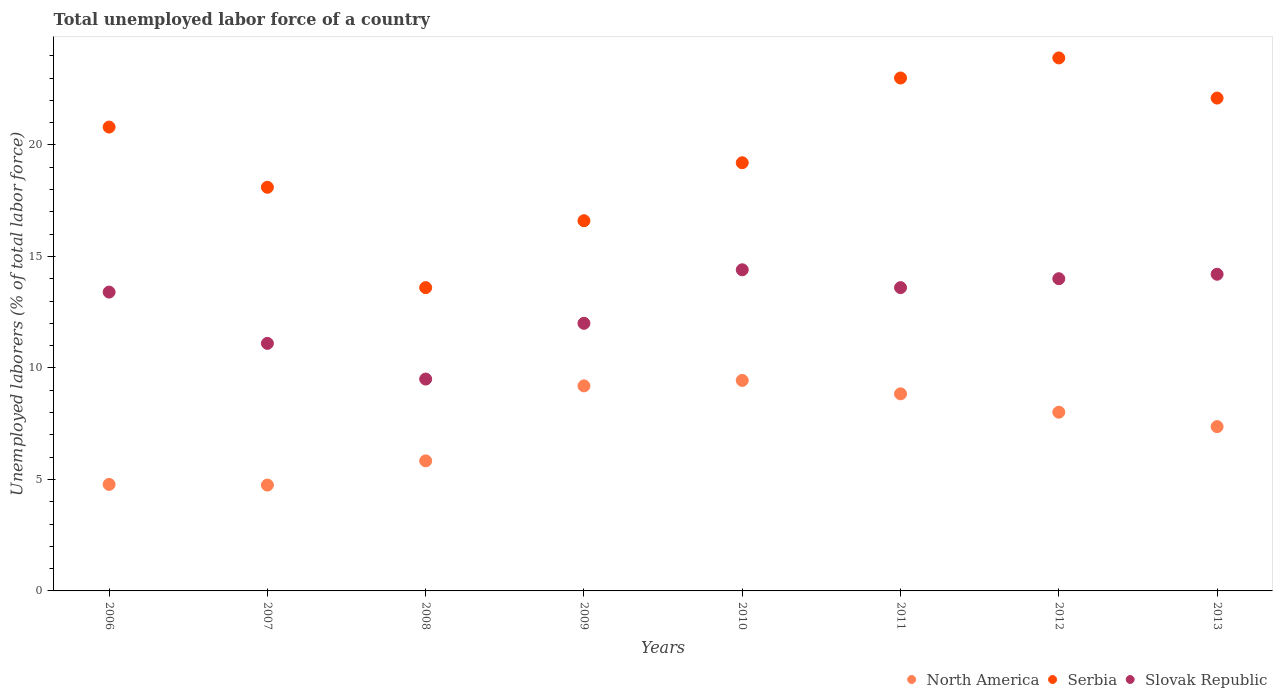How many different coloured dotlines are there?
Offer a terse response. 3. Is the number of dotlines equal to the number of legend labels?
Give a very brief answer. Yes. What is the total unemployed labor force in North America in 2011?
Give a very brief answer. 8.84. Across all years, what is the maximum total unemployed labor force in Slovak Republic?
Offer a very short reply. 14.4. Across all years, what is the minimum total unemployed labor force in Slovak Republic?
Keep it short and to the point. 9.5. In which year was the total unemployed labor force in Slovak Republic maximum?
Give a very brief answer. 2010. What is the total total unemployed labor force in North America in the graph?
Make the answer very short. 58.21. What is the difference between the total unemployed labor force in Slovak Republic in 2009 and that in 2010?
Make the answer very short. -2.4. What is the difference between the total unemployed labor force in Slovak Republic in 2013 and the total unemployed labor force in Serbia in 2010?
Offer a terse response. -5. What is the average total unemployed labor force in Slovak Republic per year?
Offer a very short reply. 12.77. In the year 2012, what is the difference between the total unemployed labor force in North America and total unemployed labor force in Serbia?
Provide a short and direct response. -15.89. What is the ratio of the total unemployed labor force in Serbia in 2009 to that in 2013?
Give a very brief answer. 0.75. What is the difference between the highest and the second highest total unemployed labor force in North America?
Your response must be concise. 0.25. What is the difference between the highest and the lowest total unemployed labor force in Slovak Republic?
Your answer should be very brief. 4.9. In how many years, is the total unemployed labor force in North America greater than the average total unemployed labor force in North America taken over all years?
Provide a succinct answer. 5. Is it the case that in every year, the sum of the total unemployed labor force in Serbia and total unemployed labor force in Slovak Republic  is greater than the total unemployed labor force in North America?
Keep it short and to the point. Yes. Does the total unemployed labor force in Slovak Republic monotonically increase over the years?
Provide a short and direct response. No. Is the total unemployed labor force in North America strictly less than the total unemployed labor force in Slovak Republic over the years?
Ensure brevity in your answer.  Yes. How many dotlines are there?
Provide a succinct answer. 3. Does the graph contain any zero values?
Your answer should be very brief. No. Does the graph contain grids?
Keep it short and to the point. No. Where does the legend appear in the graph?
Your response must be concise. Bottom right. How many legend labels are there?
Your answer should be compact. 3. What is the title of the graph?
Offer a terse response. Total unemployed labor force of a country. What is the label or title of the Y-axis?
Provide a short and direct response. Unemployed laborers (% of total labor force). What is the Unemployed laborers (% of total labor force) of North America in 2006?
Provide a succinct answer. 4.78. What is the Unemployed laborers (% of total labor force) of Serbia in 2006?
Your answer should be very brief. 20.8. What is the Unemployed laborers (% of total labor force) of Slovak Republic in 2006?
Provide a short and direct response. 13.4. What is the Unemployed laborers (% of total labor force) in North America in 2007?
Offer a very short reply. 4.75. What is the Unemployed laborers (% of total labor force) of Serbia in 2007?
Give a very brief answer. 18.1. What is the Unemployed laborers (% of total labor force) in Slovak Republic in 2007?
Ensure brevity in your answer.  11.1. What is the Unemployed laborers (% of total labor force) in North America in 2008?
Your answer should be compact. 5.83. What is the Unemployed laborers (% of total labor force) of Serbia in 2008?
Keep it short and to the point. 13.6. What is the Unemployed laborers (% of total labor force) in North America in 2009?
Your answer should be very brief. 9.19. What is the Unemployed laborers (% of total labor force) in Serbia in 2009?
Offer a terse response. 16.6. What is the Unemployed laborers (% of total labor force) of North America in 2010?
Provide a short and direct response. 9.44. What is the Unemployed laborers (% of total labor force) in Serbia in 2010?
Ensure brevity in your answer.  19.2. What is the Unemployed laborers (% of total labor force) of Slovak Republic in 2010?
Give a very brief answer. 14.4. What is the Unemployed laborers (% of total labor force) in North America in 2011?
Offer a terse response. 8.84. What is the Unemployed laborers (% of total labor force) of Slovak Republic in 2011?
Ensure brevity in your answer.  13.6. What is the Unemployed laborers (% of total labor force) in North America in 2012?
Offer a very short reply. 8.01. What is the Unemployed laborers (% of total labor force) of Serbia in 2012?
Keep it short and to the point. 23.9. What is the Unemployed laborers (% of total labor force) of Slovak Republic in 2012?
Keep it short and to the point. 14. What is the Unemployed laborers (% of total labor force) of North America in 2013?
Your response must be concise. 7.37. What is the Unemployed laborers (% of total labor force) in Serbia in 2013?
Offer a very short reply. 22.1. What is the Unemployed laborers (% of total labor force) of Slovak Republic in 2013?
Provide a succinct answer. 14.2. Across all years, what is the maximum Unemployed laborers (% of total labor force) in North America?
Your response must be concise. 9.44. Across all years, what is the maximum Unemployed laborers (% of total labor force) of Serbia?
Offer a very short reply. 23.9. Across all years, what is the maximum Unemployed laborers (% of total labor force) of Slovak Republic?
Your answer should be compact. 14.4. Across all years, what is the minimum Unemployed laborers (% of total labor force) of North America?
Keep it short and to the point. 4.75. Across all years, what is the minimum Unemployed laborers (% of total labor force) of Serbia?
Ensure brevity in your answer.  13.6. What is the total Unemployed laborers (% of total labor force) of North America in the graph?
Ensure brevity in your answer.  58.21. What is the total Unemployed laborers (% of total labor force) of Serbia in the graph?
Give a very brief answer. 157.3. What is the total Unemployed laborers (% of total labor force) of Slovak Republic in the graph?
Your answer should be very brief. 102.2. What is the difference between the Unemployed laborers (% of total labor force) of North America in 2006 and that in 2007?
Ensure brevity in your answer.  0.03. What is the difference between the Unemployed laborers (% of total labor force) of North America in 2006 and that in 2008?
Make the answer very short. -1.06. What is the difference between the Unemployed laborers (% of total labor force) in Slovak Republic in 2006 and that in 2008?
Offer a terse response. 3.9. What is the difference between the Unemployed laborers (% of total labor force) in North America in 2006 and that in 2009?
Your answer should be compact. -4.42. What is the difference between the Unemployed laborers (% of total labor force) of Serbia in 2006 and that in 2009?
Provide a succinct answer. 4.2. What is the difference between the Unemployed laborers (% of total labor force) in North America in 2006 and that in 2010?
Provide a succinct answer. -4.66. What is the difference between the Unemployed laborers (% of total labor force) of Serbia in 2006 and that in 2010?
Offer a terse response. 1.6. What is the difference between the Unemployed laborers (% of total labor force) of North America in 2006 and that in 2011?
Your response must be concise. -4.06. What is the difference between the Unemployed laborers (% of total labor force) in North America in 2006 and that in 2012?
Make the answer very short. -3.24. What is the difference between the Unemployed laborers (% of total labor force) of Slovak Republic in 2006 and that in 2012?
Offer a terse response. -0.6. What is the difference between the Unemployed laborers (% of total labor force) in North America in 2006 and that in 2013?
Your answer should be compact. -2.59. What is the difference between the Unemployed laborers (% of total labor force) of Serbia in 2006 and that in 2013?
Offer a very short reply. -1.3. What is the difference between the Unemployed laborers (% of total labor force) of Slovak Republic in 2006 and that in 2013?
Provide a short and direct response. -0.8. What is the difference between the Unemployed laborers (% of total labor force) in North America in 2007 and that in 2008?
Make the answer very short. -1.08. What is the difference between the Unemployed laborers (% of total labor force) in Serbia in 2007 and that in 2008?
Your answer should be compact. 4.5. What is the difference between the Unemployed laborers (% of total labor force) of North America in 2007 and that in 2009?
Provide a short and direct response. -4.45. What is the difference between the Unemployed laborers (% of total labor force) of Slovak Republic in 2007 and that in 2009?
Your answer should be compact. -0.9. What is the difference between the Unemployed laborers (% of total labor force) in North America in 2007 and that in 2010?
Offer a very short reply. -4.69. What is the difference between the Unemployed laborers (% of total labor force) of Serbia in 2007 and that in 2010?
Offer a very short reply. -1.1. What is the difference between the Unemployed laborers (% of total labor force) in Slovak Republic in 2007 and that in 2010?
Your answer should be very brief. -3.3. What is the difference between the Unemployed laborers (% of total labor force) of North America in 2007 and that in 2011?
Your response must be concise. -4.09. What is the difference between the Unemployed laborers (% of total labor force) in North America in 2007 and that in 2012?
Ensure brevity in your answer.  -3.27. What is the difference between the Unemployed laborers (% of total labor force) of Serbia in 2007 and that in 2012?
Ensure brevity in your answer.  -5.8. What is the difference between the Unemployed laborers (% of total labor force) of North America in 2007 and that in 2013?
Your response must be concise. -2.62. What is the difference between the Unemployed laborers (% of total labor force) of Serbia in 2007 and that in 2013?
Offer a very short reply. -4. What is the difference between the Unemployed laborers (% of total labor force) of Slovak Republic in 2007 and that in 2013?
Make the answer very short. -3.1. What is the difference between the Unemployed laborers (% of total labor force) of North America in 2008 and that in 2009?
Keep it short and to the point. -3.36. What is the difference between the Unemployed laborers (% of total labor force) in Slovak Republic in 2008 and that in 2009?
Give a very brief answer. -2.5. What is the difference between the Unemployed laborers (% of total labor force) of North America in 2008 and that in 2010?
Ensure brevity in your answer.  -3.61. What is the difference between the Unemployed laborers (% of total labor force) in Serbia in 2008 and that in 2010?
Provide a succinct answer. -5.6. What is the difference between the Unemployed laborers (% of total labor force) of Slovak Republic in 2008 and that in 2010?
Offer a terse response. -4.9. What is the difference between the Unemployed laborers (% of total labor force) in North America in 2008 and that in 2011?
Make the answer very short. -3.01. What is the difference between the Unemployed laborers (% of total labor force) in Slovak Republic in 2008 and that in 2011?
Your response must be concise. -4.1. What is the difference between the Unemployed laborers (% of total labor force) in North America in 2008 and that in 2012?
Offer a terse response. -2.18. What is the difference between the Unemployed laborers (% of total labor force) of Slovak Republic in 2008 and that in 2012?
Your answer should be very brief. -4.5. What is the difference between the Unemployed laborers (% of total labor force) of North America in 2008 and that in 2013?
Your answer should be very brief. -1.54. What is the difference between the Unemployed laborers (% of total labor force) in North America in 2009 and that in 2010?
Ensure brevity in your answer.  -0.25. What is the difference between the Unemployed laborers (% of total labor force) in Serbia in 2009 and that in 2010?
Keep it short and to the point. -2.6. What is the difference between the Unemployed laborers (% of total labor force) in Slovak Republic in 2009 and that in 2010?
Make the answer very short. -2.4. What is the difference between the Unemployed laborers (% of total labor force) in North America in 2009 and that in 2011?
Provide a succinct answer. 0.36. What is the difference between the Unemployed laborers (% of total labor force) in Serbia in 2009 and that in 2011?
Ensure brevity in your answer.  -6.4. What is the difference between the Unemployed laborers (% of total labor force) of North America in 2009 and that in 2012?
Offer a very short reply. 1.18. What is the difference between the Unemployed laborers (% of total labor force) in Slovak Republic in 2009 and that in 2012?
Your answer should be very brief. -2. What is the difference between the Unemployed laborers (% of total labor force) of North America in 2009 and that in 2013?
Ensure brevity in your answer.  1.83. What is the difference between the Unemployed laborers (% of total labor force) in Serbia in 2009 and that in 2013?
Offer a very short reply. -5.5. What is the difference between the Unemployed laborers (% of total labor force) of Slovak Republic in 2009 and that in 2013?
Ensure brevity in your answer.  -2.2. What is the difference between the Unemployed laborers (% of total labor force) of North America in 2010 and that in 2011?
Offer a very short reply. 0.6. What is the difference between the Unemployed laborers (% of total labor force) in Slovak Republic in 2010 and that in 2011?
Your response must be concise. 0.8. What is the difference between the Unemployed laborers (% of total labor force) in North America in 2010 and that in 2012?
Ensure brevity in your answer.  1.43. What is the difference between the Unemployed laborers (% of total labor force) of North America in 2010 and that in 2013?
Provide a succinct answer. 2.07. What is the difference between the Unemployed laborers (% of total labor force) in Serbia in 2010 and that in 2013?
Your response must be concise. -2.9. What is the difference between the Unemployed laborers (% of total labor force) of Slovak Republic in 2010 and that in 2013?
Your response must be concise. 0.2. What is the difference between the Unemployed laborers (% of total labor force) of North America in 2011 and that in 2012?
Make the answer very short. 0.82. What is the difference between the Unemployed laborers (% of total labor force) in Serbia in 2011 and that in 2012?
Provide a succinct answer. -0.9. What is the difference between the Unemployed laborers (% of total labor force) of Slovak Republic in 2011 and that in 2012?
Keep it short and to the point. -0.4. What is the difference between the Unemployed laborers (% of total labor force) in North America in 2011 and that in 2013?
Your answer should be compact. 1.47. What is the difference between the Unemployed laborers (% of total labor force) of Serbia in 2011 and that in 2013?
Your answer should be very brief. 0.9. What is the difference between the Unemployed laborers (% of total labor force) of North America in 2012 and that in 2013?
Keep it short and to the point. 0.65. What is the difference between the Unemployed laborers (% of total labor force) in Serbia in 2012 and that in 2013?
Give a very brief answer. 1.8. What is the difference between the Unemployed laborers (% of total labor force) of North America in 2006 and the Unemployed laborers (% of total labor force) of Serbia in 2007?
Provide a succinct answer. -13.32. What is the difference between the Unemployed laborers (% of total labor force) in North America in 2006 and the Unemployed laborers (% of total labor force) in Slovak Republic in 2007?
Your answer should be very brief. -6.32. What is the difference between the Unemployed laborers (% of total labor force) of North America in 2006 and the Unemployed laborers (% of total labor force) of Serbia in 2008?
Provide a short and direct response. -8.82. What is the difference between the Unemployed laborers (% of total labor force) of North America in 2006 and the Unemployed laborers (% of total labor force) of Slovak Republic in 2008?
Ensure brevity in your answer.  -4.72. What is the difference between the Unemployed laborers (% of total labor force) in Serbia in 2006 and the Unemployed laborers (% of total labor force) in Slovak Republic in 2008?
Keep it short and to the point. 11.3. What is the difference between the Unemployed laborers (% of total labor force) of North America in 2006 and the Unemployed laborers (% of total labor force) of Serbia in 2009?
Keep it short and to the point. -11.82. What is the difference between the Unemployed laborers (% of total labor force) in North America in 2006 and the Unemployed laborers (% of total labor force) in Slovak Republic in 2009?
Your response must be concise. -7.22. What is the difference between the Unemployed laborers (% of total labor force) in North America in 2006 and the Unemployed laborers (% of total labor force) in Serbia in 2010?
Offer a very short reply. -14.42. What is the difference between the Unemployed laborers (% of total labor force) of North America in 2006 and the Unemployed laborers (% of total labor force) of Slovak Republic in 2010?
Offer a terse response. -9.62. What is the difference between the Unemployed laborers (% of total labor force) in North America in 2006 and the Unemployed laborers (% of total labor force) in Serbia in 2011?
Ensure brevity in your answer.  -18.22. What is the difference between the Unemployed laborers (% of total labor force) of North America in 2006 and the Unemployed laborers (% of total labor force) of Slovak Republic in 2011?
Keep it short and to the point. -8.82. What is the difference between the Unemployed laborers (% of total labor force) of Serbia in 2006 and the Unemployed laborers (% of total labor force) of Slovak Republic in 2011?
Offer a terse response. 7.2. What is the difference between the Unemployed laborers (% of total labor force) in North America in 2006 and the Unemployed laborers (% of total labor force) in Serbia in 2012?
Provide a short and direct response. -19.12. What is the difference between the Unemployed laborers (% of total labor force) of North America in 2006 and the Unemployed laborers (% of total labor force) of Slovak Republic in 2012?
Provide a short and direct response. -9.22. What is the difference between the Unemployed laborers (% of total labor force) of Serbia in 2006 and the Unemployed laborers (% of total labor force) of Slovak Republic in 2012?
Make the answer very short. 6.8. What is the difference between the Unemployed laborers (% of total labor force) in North America in 2006 and the Unemployed laborers (% of total labor force) in Serbia in 2013?
Your answer should be compact. -17.32. What is the difference between the Unemployed laborers (% of total labor force) of North America in 2006 and the Unemployed laborers (% of total labor force) of Slovak Republic in 2013?
Offer a terse response. -9.42. What is the difference between the Unemployed laborers (% of total labor force) in North America in 2007 and the Unemployed laborers (% of total labor force) in Serbia in 2008?
Keep it short and to the point. -8.85. What is the difference between the Unemployed laborers (% of total labor force) of North America in 2007 and the Unemployed laborers (% of total labor force) of Slovak Republic in 2008?
Your answer should be compact. -4.75. What is the difference between the Unemployed laborers (% of total labor force) in Serbia in 2007 and the Unemployed laborers (% of total labor force) in Slovak Republic in 2008?
Make the answer very short. 8.6. What is the difference between the Unemployed laborers (% of total labor force) of North America in 2007 and the Unemployed laborers (% of total labor force) of Serbia in 2009?
Keep it short and to the point. -11.85. What is the difference between the Unemployed laborers (% of total labor force) of North America in 2007 and the Unemployed laborers (% of total labor force) of Slovak Republic in 2009?
Make the answer very short. -7.25. What is the difference between the Unemployed laborers (% of total labor force) of Serbia in 2007 and the Unemployed laborers (% of total labor force) of Slovak Republic in 2009?
Your response must be concise. 6.1. What is the difference between the Unemployed laborers (% of total labor force) of North America in 2007 and the Unemployed laborers (% of total labor force) of Serbia in 2010?
Your answer should be compact. -14.45. What is the difference between the Unemployed laborers (% of total labor force) of North America in 2007 and the Unemployed laborers (% of total labor force) of Slovak Republic in 2010?
Make the answer very short. -9.65. What is the difference between the Unemployed laborers (% of total labor force) of North America in 2007 and the Unemployed laborers (% of total labor force) of Serbia in 2011?
Ensure brevity in your answer.  -18.25. What is the difference between the Unemployed laborers (% of total labor force) in North America in 2007 and the Unemployed laborers (% of total labor force) in Slovak Republic in 2011?
Your response must be concise. -8.85. What is the difference between the Unemployed laborers (% of total labor force) in North America in 2007 and the Unemployed laborers (% of total labor force) in Serbia in 2012?
Your answer should be very brief. -19.15. What is the difference between the Unemployed laborers (% of total labor force) of North America in 2007 and the Unemployed laborers (% of total labor force) of Slovak Republic in 2012?
Keep it short and to the point. -9.25. What is the difference between the Unemployed laborers (% of total labor force) of North America in 2007 and the Unemployed laborers (% of total labor force) of Serbia in 2013?
Give a very brief answer. -17.35. What is the difference between the Unemployed laborers (% of total labor force) of North America in 2007 and the Unemployed laborers (% of total labor force) of Slovak Republic in 2013?
Your response must be concise. -9.45. What is the difference between the Unemployed laborers (% of total labor force) in Serbia in 2007 and the Unemployed laborers (% of total labor force) in Slovak Republic in 2013?
Give a very brief answer. 3.9. What is the difference between the Unemployed laborers (% of total labor force) in North America in 2008 and the Unemployed laborers (% of total labor force) in Serbia in 2009?
Your response must be concise. -10.77. What is the difference between the Unemployed laborers (% of total labor force) of North America in 2008 and the Unemployed laborers (% of total labor force) of Slovak Republic in 2009?
Keep it short and to the point. -6.17. What is the difference between the Unemployed laborers (% of total labor force) in Serbia in 2008 and the Unemployed laborers (% of total labor force) in Slovak Republic in 2009?
Ensure brevity in your answer.  1.6. What is the difference between the Unemployed laborers (% of total labor force) of North America in 2008 and the Unemployed laborers (% of total labor force) of Serbia in 2010?
Offer a terse response. -13.37. What is the difference between the Unemployed laborers (% of total labor force) of North America in 2008 and the Unemployed laborers (% of total labor force) of Slovak Republic in 2010?
Offer a terse response. -8.57. What is the difference between the Unemployed laborers (% of total labor force) of Serbia in 2008 and the Unemployed laborers (% of total labor force) of Slovak Republic in 2010?
Give a very brief answer. -0.8. What is the difference between the Unemployed laborers (% of total labor force) in North America in 2008 and the Unemployed laborers (% of total labor force) in Serbia in 2011?
Your answer should be compact. -17.17. What is the difference between the Unemployed laborers (% of total labor force) of North America in 2008 and the Unemployed laborers (% of total labor force) of Slovak Republic in 2011?
Your answer should be compact. -7.77. What is the difference between the Unemployed laborers (% of total labor force) in Serbia in 2008 and the Unemployed laborers (% of total labor force) in Slovak Republic in 2011?
Keep it short and to the point. 0. What is the difference between the Unemployed laborers (% of total labor force) of North America in 2008 and the Unemployed laborers (% of total labor force) of Serbia in 2012?
Provide a succinct answer. -18.07. What is the difference between the Unemployed laborers (% of total labor force) of North America in 2008 and the Unemployed laborers (% of total labor force) of Slovak Republic in 2012?
Provide a succinct answer. -8.17. What is the difference between the Unemployed laborers (% of total labor force) in North America in 2008 and the Unemployed laborers (% of total labor force) in Serbia in 2013?
Offer a terse response. -16.27. What is the difference between the Unemployed laborers (% of total labor force) in North America in 2008 and the Unemployed laborers (% of total labor force) in Slovak Republic in 2013?
Give a very brief answer. -8.37. What is the difference between the Unemployed laborers (% of total labor force) in North America in 2009 and the Unemployed laborers (% of total labor force) in Serbia in 2010?
Make the answer very short. -10.01. What is the difference between the Unemployed laborers (% of total labor force) in North America in 2009 and the Unemployed laborers (% of total labor force) in Slovak Republic in 2010?
Make the answer very short. -5.21. What is the difference between the Unemployed laborers (% of total labor force) in North America in 2009 and the Unemployed laborers (% of total labor force) in Serbia in 2011?
Your response must be concise. -13.81. What is the difference between the Unemployed laborers (% of total labor force) of North America in 2009 and the Unemployed laborers (% of total labor force) of Slovak Republic in 2011?
Your answer should be compact. -4.41. What is the difference between the Unemployed laborers (% of total labor force) of Serbia in 2009 and the Unemployed laborers (% of total labor force) of Slovak Republic in 2011?
Provide a succinct answer. 3. What is the difference between the Unemployed laborers (% of total labor force) in North America in 2009 and the Unemployed laborers (% of total labor force) in Serbia in 2012?
Make the answer very short. -14.71. What is the difference between the Unemployed laborers (% of total labor force) in North America in 2009 and the Unemployed laborers (% of total labor force) in Slovak Republic in 2012?
Provide a short and direct response. -4.81. What is the difference between the Unemployed laborers (% of total labor force) of North America in 2009 and the Unemployed laborers (% of total labor force) of Serbia in 2013?
Offer a terse response. -12.91. What is the difference between the Unemployed laborers (% of total labor force) of North America in 2009 and the Unemployed laborers (% of total labor force) of Slovak Republic in 2013?
Give a very brief answer. -5.01. What is the difference between the Unemployed laborers (% of total labor force) of North America in 2010 and the Unemployed laborers (% of total labor force) of Serbia in 2011?
Provide a short and direct response. -13.56. What is the difference between the Unemployed laborers (% of total labor force) of North America in 2010 and the Unemployed laborers (% of total labor force) of Slovak Republic in 2011?
Offer a terse response. -4.16. What is the difference between the Unemployed laborers (% of total labor force) in North America in 2010 and the Unemployed laborers (% of total labor force) in Serbia in 2012?
Provide a short and direct response. -14.46. What is the difference between the Unemployed laborers (% of total labor force) of North America in 2010 and the Unemployed laborers (% of total labor force) of Slovak Republic in 2012?
Give a very brief answer. -4.56. What is the difference between the Unemployed laborers (% of total labor force) of North America in 2010 and the Unemployed laborers (% of total labor force) of Serbia in 2013?
Give a very brief answer. -12.66. What is the difference between the Unemployed laborers (% of total labor force) in North America in 2010 and the Unemployed laborers (% of total labor force) in Slovak Republic in 2013?
Your response must be concise. -4.76. What is the difference between the Unemployed laborers (% of total labor force) of North America in 2011 and the Unemployed laborers (% of total labor force) of Serbia in 2012?
Offer a terse response. -15.06. What is the difference between the Unemployed laborers (% of total labor force) of North America in 2011 and the Unemployed laborers (% of total labor force) of Slovak Republic in 2012?
Give a very brief answer. -5.16. What is the difference between the Unemployed laborers (% of total labor force) in North America in 2011 and the Unemployed laborers (% of total labor force) in Serbia in 2013?
Keep it short and to the point. -13.26. What is the difference between the Unemployed laborers (% of total labor force) in North America in 2011 and the Unemployed laborers (% of total labor force) in Slovak Republic in 2013?
Keep it short and to the point. -5.36. What is the difference between the Unemployed laborers (% of total labor force) of Serbia in 2011 and the Unemployed laborers (% of total labor force) of Slovak Republic in 2013?
Offer a very short reply. 8.8. What is the difference between the Unemployed laborers (% of total labor force) in North America in 2012 and the Unemployed laborers (% of total labor force) in Serbia in 2013?
Offer a very short reply. -14.09. What is the difference between the Unemployed laborers (% of total labor force) in North America in 2012 and the Unemployed laborers (% of total labor force) in Slovak Republic in 2013?
Make the answer very short. -6.19. What is the average Unemployed laborers (% of total labor force) in North America per year?
Make the answer very short. 7.28. What is the average Unemployed laborers (% of total labor force) in Serbia per year?
Make the answer very short. 19.66. What is the average Unemployed laborers (% of total labor force) of Slovak Republic per year?
Your answer should be very brief. 12.78. In the year 2006, what is the difference between the Unemployed laborers (% of total labor force) of North America and Unemployed laborers (% of total labor force) of Serbia?
Offer a terse response. -16.02. In the year 2006, what is the difference between the Unemployed laborers (% of total labor force) of North America and Unemployed laborers (% of total labor force) of Slovak Republic?
Give a very brief answer. -8.62. In the year 2007, what is the difference between the Unemployed laborers (% of total labor force) of North America and Unemployed laborers (% of total labor force) of Serbia?
Offer a terse response. -13.35. In the year 2007, what is the difference between the Unemployed laborers (% of total labor force) in North America and Unemployed laborers (% of total labor force) in Slovak Republic?
Your response must be concise. -6.35. In the year 2008, what is the difference between the Unemployed laborers (% of total labor force) of North America and Unemployed laborers (% of total labor force) of Serbia?
Offer a terse response. -7.77. In the year 2008, what is the difference between the Unemployed laborers (% of total labor force) in North America and Unemployed laborers (% of total labor force) in Slovak Republic?
Give a very brief answer. -3.67. In the year 2009, what is the difference between the Unemployed laborers (% of total labor force) in North America and Unemployed laborers (% of total labor force) in Serbia?
Keep it short and to the point. -7.41. In the year 2009, what is the difference between the Unemployed laborers (% of total labor force) in North America and Unemployed laborers (% of total labor force) in Slovak Republic?
Your answer should be very brief. -2.81. In the year 2009, what is the difference between the Unemployed laborers (% of total labor force) of Serbia and Unemployed laborers (% of total labor force) of Slovak Republic?
Your response must be concise. 4.6. In the year 2010, what is the difference between the Unemployed laborers (% of total labor force) in North America and Unemployed laborers (% of total labor force) in Serbia?
Provide a short and direct response. -9.76. In the year 2010, what is the difference between the Unemployed laborers (% of total labor force) of North America and Unemployed laborers (% of total labor force) of Slovak Republic?
Your response must be concise. -4.96. In the year 2010, what is the difference between the Unemployed laborers (% of total labor force) in Serbia and Unemployed laborers (% of total labor force) in Slovak Republic?
Make the answer very short. 4.8. In the year 2011, what is the difference between the Unemployed laborers (% of total labor force) of North America and Unemployed laborers (% of total labor force) of Serbia?
Give a very brief answer. -14.16. In the year 2011, what is the difference between the Unemployed laborers (% of total labor force) in North America and Unemployed laborers (% of total labor force) in Slovak Republic?
Keep it short and to the point. -4.76. In the year 2011, what is the difference between the Unemployed laborers (% of total labor force) of Serbia and Unemployed laborers (% of total labor force) of Slovak Republic?
Offer a terse response. 9.4. In the year 2012, what is the difference between the Unemployed laborers (% of total labor force) of North America and Unemployed laborers (% of total labor force) of Serbia?
Keep it short and to the point. -15.89. In the year 2012, what is the difference between the Unemployed laborers (% of total labor force) in North America and Unemployed laborers (% of total labor force) in Slovak Republic?
Your answer should be very brief. -5.99. In the year 2013, what is the difference between the Unemployed laborers (% of total labor force) in North America and Unemployed laborers (% of total labor force) in Serbia?
Your answer should be very brief. -14.73. In the year 2013, what is the difference between the Unemployed laborers (% of total labor force) of North America and Unemployed laborers (% of total labor force) of Slovak Republic?
Your answer should be compact. -6.83. In the year 2013, what is the difference between the Unemployed laborers (% of total labor force) of Serbia and Unemployed laborers (% of total labor force) of Slovak Republic?
Provide a succinct answer. 7.9. What is the ratio of the Unemployed laborers (% of total labor force) of Serbia in 2006 to that in 2007?
Your answer should be very brief. 1.15. What is the ratio of the Unemployed laborers (% of total labor force) of Slovak Republic in 2006 to that in 2007?
Provide a succinct answer. 1.21. What is the ratio of the Unemployed laborers (% of total labor force) in North America in 2006 to that in 2008?
Your answer should be compact. 0.82. What is the ratio of the Unemployed laborers (% of total labor force) in Serbia in 2006 to that in 2008?
Your response must be concise. 1.53. What is the ratio of the Unemployed laborers (% of total labor force) in Slovak Republic in 2006 to that in 2008?
Your answer should be compact. 1.41. What is the ratio of the Unemployed laborers (% of total labor force) of North America in 2006 to that in 2009?
Your answer should be very brief. 0.52. What is the ratio of the Unemployed laborers (% of total labor force) in Serbia in 2006 to that in 2009?
Your response must be concise. 1.25. What is the ratio of the Unemployed laborers (% of total labor force) of Slovak Republic in 2006 to that in 2009?
Make the answer very short. 1.12. What is the ratio of the Unemployed laborers (% of total labor force) of North America in 2006 to that in 2010?
Offer a very short reply. 0.51. What is the ratio of the Unemployed laborers (% of total labor force) in Slovak Republic in 2006 to that in 2010?
Your answer should be very brief. 0.93. What is the ratio of the Unemployed laborers (% of total labor force) of North America in 2006 to that in 2011?
Provide a succinct answer. 0.54. What is the ratio of the Unemployed laborers (% of total labor force) of Serbia in 2006 to that in 2011?
Your answer should be compact. 0.9. What is the ratio of the Unemployed laborers (% of total labor force) of North America in 2006 to that in 2012?
Keep it short and to the point. 0.6. What is the ratio of the Unemployed laborers (% of total labor force) of Serbia in 2006 to that in 2012?
Offer a terse response. 0.87. What is the ratio of the Unemployed laborers (% of total labor force) of Slovak Republic in 2006 to that in 2012?
Your answer should be very brief. 0.96. What is the ratio of the Unemployed laborers (% of total labor force) in North America in 2006 to that in 2013?
Offer a very short reply. 0.65. What is the ratio of the Unemployed laborers (% of total labor force) in Slovak Republic in 2006 to that in 2013?
Your answer should be very brief. 0.94. What is the ratio of the Unemployed laborers (% of total labor force) of North America in 2007 to that in 2008?
Provide a short and direct response. 0.81. What is the ratio of the Unemployed laborers (% of total labor force) in Serbia in 2007 to that in 2008?
Your response must be concise. 1.33. What is the ratio of the Unemployed laborers (% of total labor force) in Slovak Republic in 2007 to that in 2008?
Give a very brief answer. 1.17. What is the ratio of the Unemployed laborers (% of total labor force) in North America in 2007 to that in 2009?
Your response must be concise. 0.52. What is the ratio of the Unemployed laborers (% of total labor force) in Serbia in 2007 to that in 2009?
Offer a terse response. 1.09. What is the ratio of the Unemployed laborers (% of total labor force) in Slovak Republic in 2007 to that in 2009?
Ensure brevity in your answer.  0.93. What is the ratio of the Unemployed laborers (% of total labor force) of North America in 2007 to that in 2010?
Your answer should be compact. 0.5. What is the ratio of the Unemployed laborers (% of total labor force) of Serbia in 2007 to that in 2010?
Offer a terse response. 0.94. What is the ratio of the Unemployed laborers (% of total labor force) in Slovak Republic in 2007 to that in 2010?
Keep it short and to the point. 0.77. What is the ratio of the Unemployed laborers (% of total labor force) in North America in 2007 to that in 2011?
Provide a short and direct response. 0.54. What is the ratio of the Unemployed laborers (% of total labor force) in Serbia in 2007 to that in 2011?
Offer a very short reply. 0.79. What is the ratio of the Unemployed laborers (% of total labor force) in Slovak Republic in 2007 to that in 2011?
Ensure brevity in your answer.  0.82. What is the ratio of the Unemployed laborers (% of total labor force) in North America in 2007 to that in 2012?
Offer a very short reply. 0.59. What is the ratio of the Unemployed laborers (% of total labor force) in Serbia in 2007 to that in 2012?
Provide a succinct answer. 0.76. What is the ratio of the Unemployed laborers (% of total labor force) of Slovak Republic in 2007 to that in 2012?
Provide a succinct answer. 0.79. What is the ratio of the Unemployed laborers (% of total labor force) of North America in 2007 to that in 2013?
Your answer should be very brief. 0.64. What is the ratio of the Unemployed laborers (% of total labor force) in Serbia in 2007 to that in 2013?
Provide a short and direct response. 0.82. What is the ratio of the Unemployed laborers (% of total labor force) of Slovak Republic in 2007 to that in 2013?
Provide a short and direct response. 0.78. What is the ratio of the Unemployed laborers (% of total labor force) of North America in 2008 to that in 2009?
Ensure brevity in your answer.  0.63. What is the ratio of the Unemployed laborers (% of total labor force) in Serbia in 2008 to that in 2009?
Your response must be concise. 0.82. What is the ratio of the Unemployed laborers (% of total labor force) of Slovak Republic in 2008 to that in 2009?
Give a very brief answer. 0.79. What is the ratio of the Unemployed laborers (% of total labor force) in North America in 2008 to that in 2010?
Your answer should be compact. 0.62. What is the ratio of the Unemployed laborers (% of total labor force) in Serbia in 2008 to that in 2010?
Your answer should be very brief. 0.71. What is the ratio of the Unemployed laborers (% of total labor force) of Slovak Republic in 2008 to that in 2010?
Make the answer very short. 0.66. What is the ratio of the Unemployed laborers (% of total labor force) of North America in 2008 to that in 2011?
Your response must be concise. 0.66. What is the ratio of the Unemployed laborers (% of total labor force) of Serbia in 2008 to that in 2011?
Provide a short and direct response. 0.59. What is the ratio of the Unemployed laborers (% of total labor force) of Slovak Republic in 2008 to that in 2011?
Your answer should be compact. 0.7. What is the ratio of the Unemployed laborers (% of total labor force) of North America in 2008 to that in 2012?
Give a very brief answer. 0.73. What is the ratio of the Unemployed laborers (% of total labor force) of Serbia in 2008 to that in 2012?
Give a very brief answer. 0.57. What is the ratio of the Unemployed laborers (% of total labor force) in Slovak Republic in 2008 to that in 2012?
Give a very brief answer. 0.68. What is the ratio of the Unemployed laborers (% of total labor force) of North America in 2008 to that in 2013?
Your answer should be compact. 0.79. What is the ratio of the Unemployed laborers (% of total labor force) of Serbia in 2008 to that in 2013?
Keep it short and to the point. 0.62. What is the ratio of the Unemployed laborers (% of total labor force) in Slovak Republic in 2008 to that in 2013?
Your answer should be compact. 0.67. What is the ratio of the Unemployed laborers (% of total labor force) in Serbia in 2009 to that in 2010?
Your answer should be compact. 0.86. What is the ratio of the Unemployed laborers (% of total labor force) of North America in 2009 to that in 2011?
Keep it short and to the point. 1.04. What is the ratio of the Unemployed laborers (% of total labor force) in Serbia in 2009 to that in 2011?
Keep it short and to the point. 0.72. What is the ratio of the Unemployed laborers (% of total labor force) in Slovak Republic in 2009 to that in 2011?
Give a very brief answer. 0.88. What is the ratio of the Unemployed laborers (% of total labor force) in North America in 2009 to that in 2012?
Give a very brief answer. 1.15. What is the ratio of the Unemployed laborers (% of total labor force) of Serbia in 2009 to that in 2012?
Ensure brevity in your answer.  0.69. What is the ratio of the Unemployed laborers (% of total labor force) in North America in 2009 to that in 2013?
Your response must be concise. 1.25. What is the ratio of the Unemployed laborers (% of total labor force) of Serbia in 2009 to that in 2013?
Your answer should be very brief. 0.75. What is the ratio of the Unemployed laborers (% of total labor force) of Slovak Republic in 2009 to that in 2013?
Provide a short and direct response. 0.85. What is the ratio of the Unemployed laborers (% of total labor force) in North America in 2010 to that in 2011?
Ensure brevity in your answer.  1.07. What is the ratio of the Unemployed laborers (% of total labor force) in Serbia in 2010 to that in 2011?
Provide a succinct answer. 0.83. What is the ratio of the Unemployed laborers (% of total labor force) in Slovak Republic in 2010 to that in 2011?
Ensure brevity in your answer.  1.06. What is the ratio of the Unemployed laborers (% of total labor force) of North America in 2010 to that in 2012?
Your answer should be compact. 1.18. What is the ratio of the Unemployed laborers (% of total labor force) of Serbia in 2010 to that in 2012?
Provide a short and direct response. 0.8. What is the ratio of the Unemployed laborers (% of total labor force) in Slovak Republic in 2010 to that in 2012?
Keep it short and to the point. 1.03. What is the ratio of the Unemployed laborers (% of total labor force) in North America in 2010 to that in 2013?
Ensure brevity in your answer.  1.28. What is the ratio of the Unemployed laborers (% of total labor force) of Serbia in 2010 to that in 2013?
Offer a terse response. 0.87. What is the ratio of the Unemployed laborers (% of total labor force) in Slovak Republic in 2010 to that in 2013?
Your answer should be compact. 1.01. What is the ratio of the Unemployed laborers (% of total labor force) of North America in 2011 to that in 2012?
Your answer should be compact. 1.1. What is the ratio of the Unemployed laborers (% of total labor force) of Serbia in 2011 to that in 2012?
Make the answer very short. 0.96. What is the ratio of the Unemployed laborers (% of total labor force) of Slovak Republic in 2011 to that in 2012?
Provide a succinct answer. 0.97. What is the ratio of the Unemployed laborers (% of total labor force) in North America in 2011 to that in 2013?
Your answer should be compact. 1.2. What is the ratio of the Unemployed laborers (% of total labor force) in Serbia in 2011 to that in 2013?
Make the answer very short. 1.04. What is the ratio of the Unemployed laborers (% of total labor force) of Slovak Republic in 2011 to that in 2013?
Provide a succinct answer. 0.96. What is the ratio of the Unemployed laborers (% of total labor force) of North America in 2012 to that in 2013?
Offer a very short reply. 1.09. What is the ratio of the Unemployed laborers (% of total labor force) of Serbia in 2012 to that in 2013?
Provide a short and direct response. 1.08. What is the ratio of the Unemployed laborers (% of total labor force) of Slovak Republic in 2012 to that in 2013?
Make the answer very short. 0.99. What is the difference between the highest and the second highest Unemployed laborers (% of total labor force) in North America?
Keep it short and to the point. 0.25. What is the difference between the highest and the lowest Unemployed laborers (% of total labor force) of North America?
Your response must be concise. 4.69. 